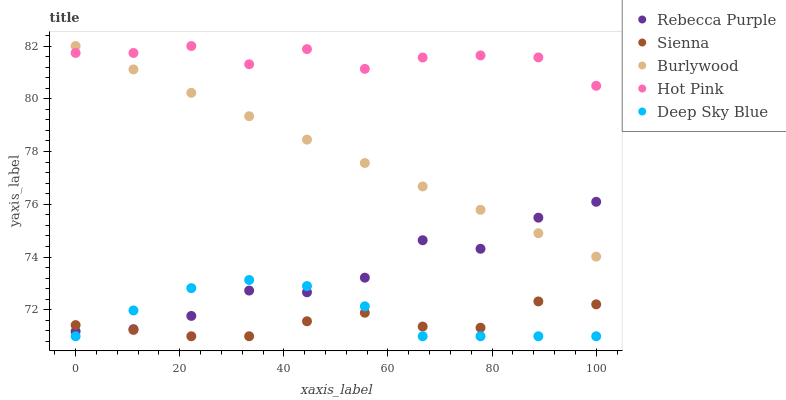Does Sienna have the minimum area under the curve?
Answer yes or no. Yes. Does Hot Pink have the maximum area under the curve?
Answer yes or no. Yes. Does Burlywood have the minimum area under the curve?
Answer yes or no. No. Does Burlywood have the maximum area under the curve?
Answer yes or no. No. Is Burlywood the smoothest?
Answer yes or no. Yes. Is Rebecca Purple the roughest?
Answer yes or no. Yes. Is Hot Pink the smoothest?
Answer yes or no. No. Is Hot Pink the roughest?
Answer yes or no. No. Does Sienna have the lowest value?
Answer yes or no. Yes. Does Burlywood have the lowest value?
Answer yes or no. No. Does Hot Pink have the highest value?
Answer yes or no. Yes. Does Rebecca Purple have the highest value?
Answer yes or no. No. Is Rebecca Purple less than Hot Pink?
Answer yes or no. Yes. Is Hot Pink greater than Rebecca Purple?
Answer yes or no. Yes. Does Deep Sky Blue intersect Rebecca Purple?
Answer yes or no. Yes. Is Deep Sky Blue less than Rebecca Purple?
Answer yes or no. No. Is Deep Sky Blue greater than Rebecca Purple?
Answer yes or no. No. Does Rebecca Purple intersect Hot Pink?
Answer yes or no. No. 